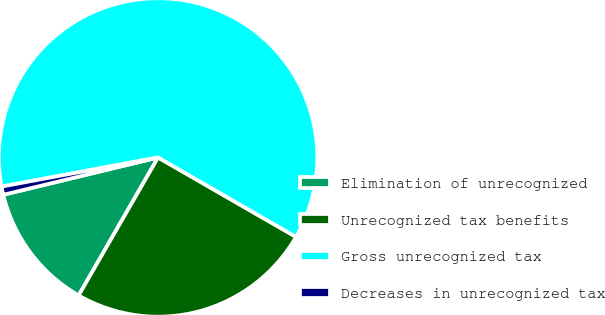<chart> <loc_0><loc_0><loc_500><loc_500><pie_chart><fcel>Elimination of unrecognized<fcel>Unrecognized tax benefits<fcel>Gross unrecognized tax<fcel>Decreases in unrecognized tax<nl><fcel>12.92%<fcel>25.0%<fcel>61.25%<fcel>0.84%<nl></chart> 